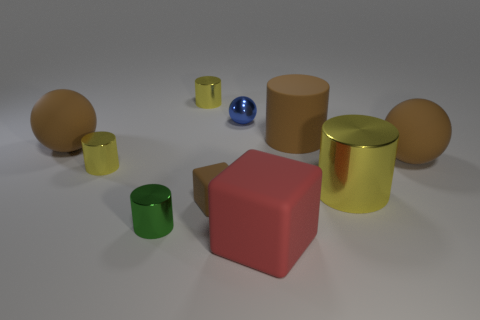How many yellow cylinders must be subtracted to get 1 yellow cylinders? 2 Subtract all brown balls. How many yellow cylinders are left? 3 Subtract all green cylinders. How many cylinders are left? 4 Subtract all brown cylinders. How many cylinders are left? 4 Subtract all gray cylinders. Subtract all yellow balls. How many cylinders are left? 5 Subtract all cubes. How many objects are left? 8 Add 8 large cyan spheres. How many large cyan spheres exist? 8 Subtract 1 blue spheres. How many objects are left? 9 Subtract all large yellow objects. Subtract all large yellow objects. How many objects are left? 8 Add 4 small yellow shiny cylinders. How many small yellow shiny cylinders are left? 6 